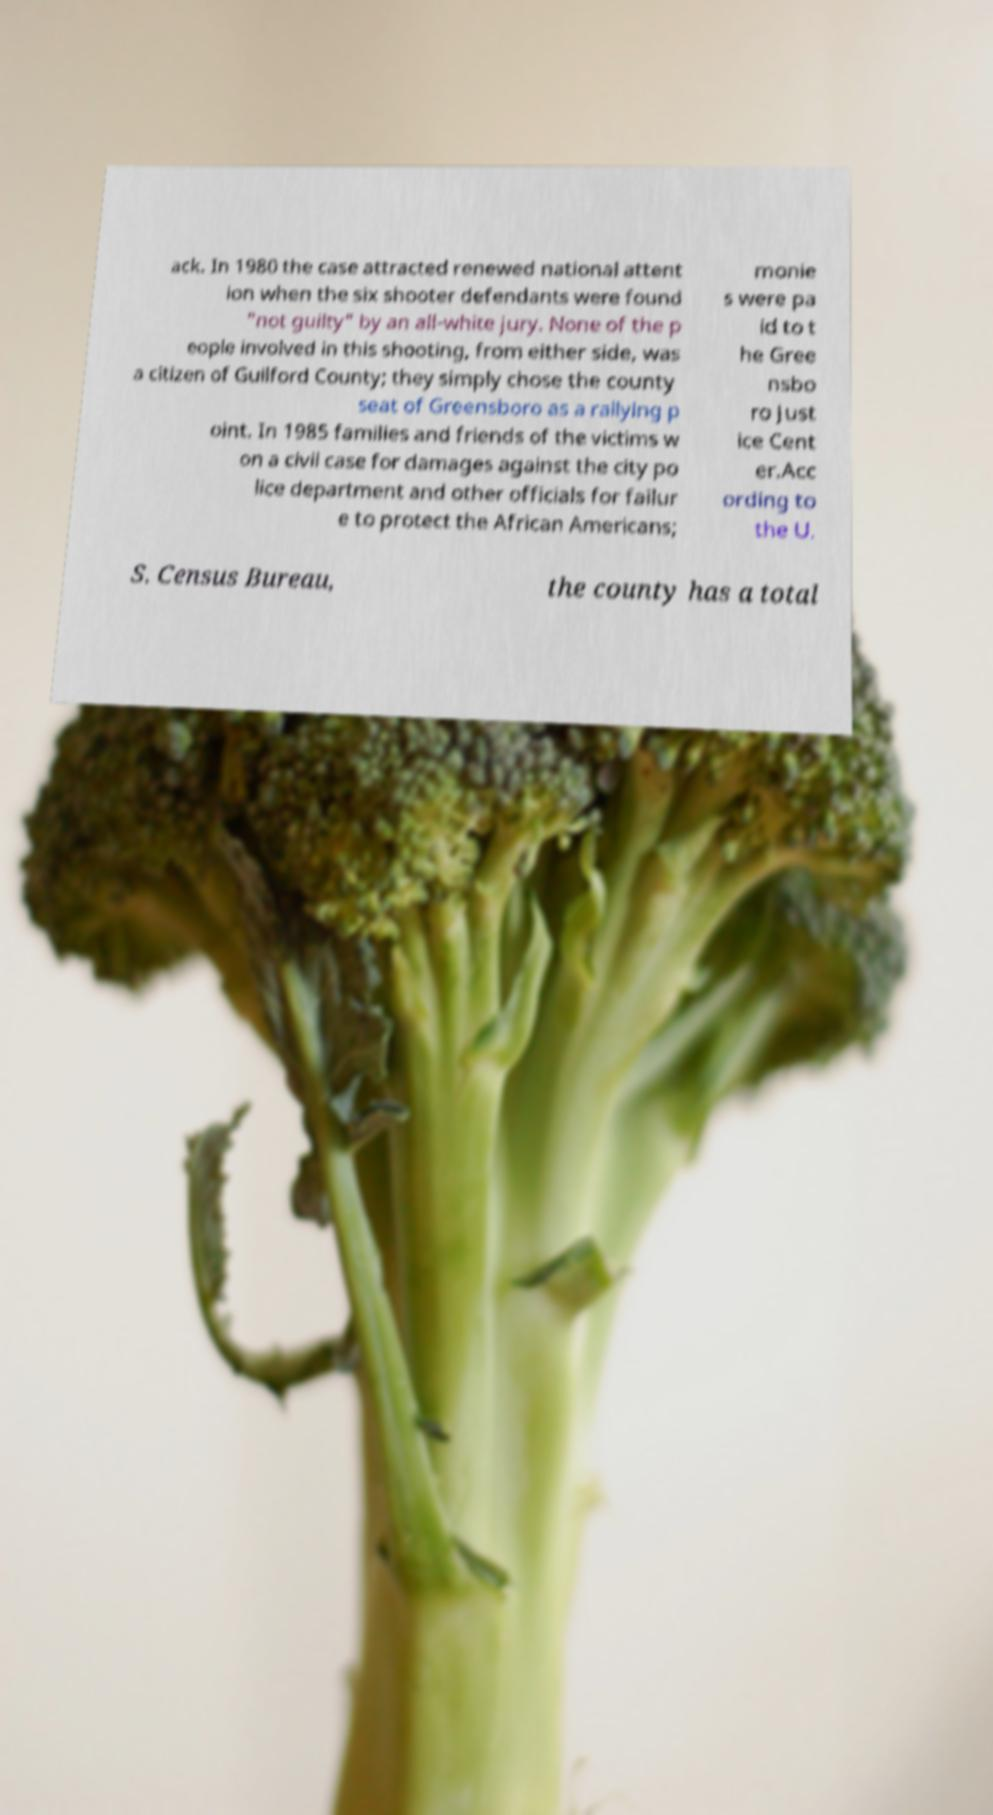Can you accurately transcribe the text from the provided image for me? ack. In 1980 the case attracted renewed national attent ion when the six shooter defendants were found "not guilty" by an all-white jury. None of the p eople involved in this shooting, from either side, was a citizen of Guilford County; they simply chose the county seat of Greensboro as a rallying p oint. In 1985 families and friends of the victims w on a civil case for damages against the city po lice department and other officials for failur e to protect the African Americans; monie s were pa id to t he Gree nsbo ro Just ice Cent er.Acc ording to the U. S. Census Bureau, the county has a total 